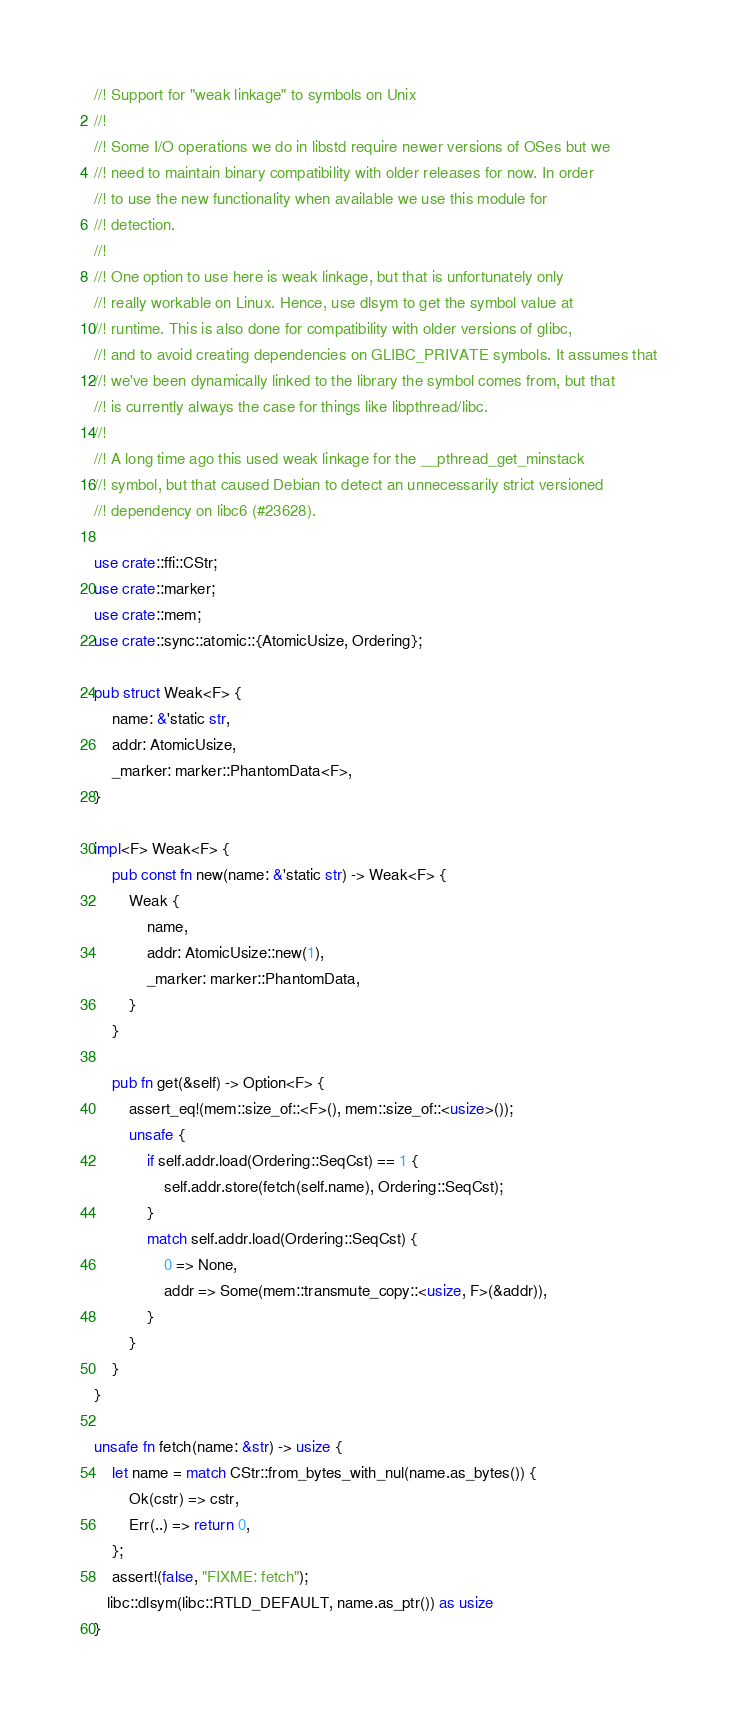Convert code to text. <code><loc_0><loc_0><loc_500><loc_500><_Rust_>//! Support for "weak linkage" to symbols on Unix
//!
//! Some I/O operations we do in libstd require newer versions of OSes but we
//! need to maintain binary compatibility with older releases for now. In order
//! to use the new functionality when available we use this module for
//! detection.
//!
//! One option to use here is weak linkage, but that is unfortunately only
//! really workable on Linux. Hence, use dlsym to get the symbol value at
//! runtime. This is also done for compatibility with older versions of glibc,
//! and to avoid creating dependencies on GLIBC_PRIVATE symbols. It assumes that
//! we've been dynamically linked to the library the symbol comes from, but that
//! is currently always the case for things like libpthread/libc.
//!
//! A long time ago this used weak linkage for the __pthread_get_minstack
//! symbol, but that caused Debian to detect an unnecessarily strict versioned
//! dependency on libc6 (#23628).

use crate::ffi::CStr;
use crate::marker;
use crate::mem;
use crate::sync::atomic::{AtomicUsize, Ordering};

pub struct Weak<F> {
    name: &'static str,
    addr: AtomicUsize,
    _marker: marker::PhantomData<F>,
}

impl<F> Weak<F> {
    pub const fn new(name: &'static str) -> Weak<F> {
        Weak {
            name,
            addr: AtomicUsize::new(1),
            _marker: marker::PhantomData,
        }
    }

    pub fn get(&self) -> Option<F> {
        assert_eq!(mem::size_of::<F>(), mem::size_of::<usize>());
        unsafe {
            if self.addr.load(Ordering::SeqCst) == 1 {
                self.addr.store(fetch(self.name), Ordering::SeqCst);
            }
            match self.addr.load(Ordering::SeqCst) {
                0 => None,
                addr => Some(mem::transmute_copy::<usize, F>(&addr)),
            }
        }
    }
}

unsafe fn fetch(name: &str) -> usize {
    let name = match CStr::from_bytes_with_nul(name.as_bytes()) {
        Ok(cstr) => cstr,
        Err(..) => return 0,
    };
    assert!(false, "FIXME: fetch");
   libc::dlsym(libc::RTLD_DEFAULT, name.as_ptr()) as usize
}
</code> 